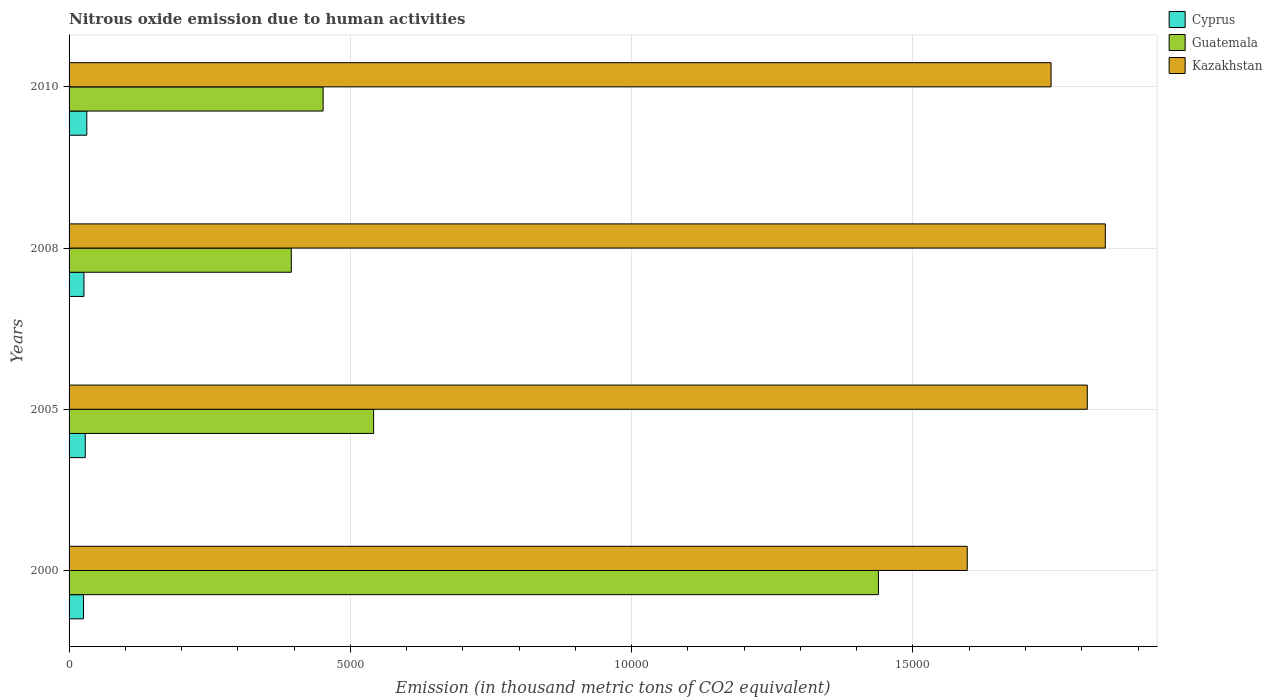How many different coloured bars are there?
Provide a succinct answer. 3. How many groups of bars are there?
Provide a succinct answer. 4. Are the number of bars on each tick of the Y-axis equal?
Offer a terse response. Yes. What is the label of the 1st group of bars from the top?
Your response must be concise. 2010. In how many cases, is the number of bars for a given year not equal to the number of legend labels?
Your answer should be very brief. 0. What is the amount of nitrous oxide emitted in Guatemala in 2005?
Your response must be concise. 5413.1. Across all years, what is the maximum amount of nitrous oxide emitted in Guatemala?
Make the answer very short. 1.44e+04. Across all years, what is the minimum amount of nitrous oxide emitted in Guatemala?
Provide a short and direct response. 3950.2. In which year was the amount of nitrous oxide emitted in Kazakhstan maximum?
Your answer should be compact. 2008. In which year was the amount of nitrous oxide emitted in Guatemala minimum?
Offer a terse response. 2008. What is the total amount of nitrous oxide emitted in Cyprus in the graph?
Offer a very short reply. 1123.4. What is the difference between the amount of nitrous oxide emitted in Kazakhstan in 2008 and that in 2010?
Keep it short and to the point. 964.4. What is the difference between the amount of nitrous oxide emitted in Cyprus in 2010 and the amount of nitrous oxide emitted in Guatemala in 2008?
Provide a succinct answer. -3635. What is the average amount of nitrous oxide emitted in Kazakhstan per year?
Give a very brief answer. 1.75e+04. In the year 2000, what is the difference between the amount of nitrous oxide emitted in Kazakhstan and amount of nitrous oxide emitted in Cyprus?
Make the answer very short. 1.57e+04. What is the ratio of the amount of nitrous oxide emitted in Cyprus in 2000 to that in 2005?
Offer a very short reply. 0.89. Is the difference between the amount of nitrous oxide emitted in Kazakhstan in 2000 and 2008 greater than the difference between the amount of nitrous oxide emitted in Cyprus in 2000 and 2008?
Provide a short and direct response. No. What is the difference between the highest and the second highest amount of nitrous oxide emitted in Guatemala?
Ensure brevity in your answer.  8972.6. What is the difference between the highest and the lowest amount of nitrous oxide emitted in Kazakhstan?
Give a very brief answer. 2454. In how many years, is the amount of nitrous oxide emitted in Kazakhstan greater than the average amount of nitrous oxide emitted in Kazakhstan taken over all years?
Your response must be concise. 2. What does the 2nd bar from the top in 2005 represents?
Your answer should be compact. Guatemala. What does the 1st bar from the bottom in 2008 represents?
Your response must be concise. Cyprus. How many bars are there?
Your answer should be very brief. 12. How many years are there in the graph?
Provide a short and direct response. 4. What is the difference between two consecutive major ticks on the X-axis?
Provide a short and direct response. 5000. Are the values on the major ticks of X-axis written in scientific E-notation?
Your answer should be very brief. No. Does the graph contain any zero values?
Give a very brief answer. No. What is the title of the graph?
Your response must be concise. Nitrous oxide emission due to human activities. What is the label or title of the X-axis?
Make the answer very short. Emission (in thousand metric tons of CO2 equivalent). What is the label or title of the Y-axis?
Offer a terse response. Years. What is the Emission (in thousand metric tons of CO2 equivalent) in Cyprus in 2000?
Offer a terse response. 255.9. What is the Emission (in thousand metric tons of CO2 equivalent) in Guatemala in 2000?
Your answer should be compact. 1.44e+04. What is the Emission (in thousand metric tons of CO2 equivalent) in Kazakhstan in 2000?
Your response must be concise. 1.60e+04. What is the Emission (in thousand metric tons of CO2 equivalent) of Cyprus in 2005?
Ensure brevity in your answer.  287.8. What is the Emission (in thousand metric tons of CO2 equivalent) in Guatemala in 2005?
Offer a very short reply. 5413.1. What is the Emission (in thousand metric tons of CO2 equivalent) of Kazakhstan in 2005?
Offer a terse response. 1.81e+04. What is the Emission (in thousand metric tons of CO2 equivalent) in Cyprus in 2008?
Your answer should be very brief. 264.5. What is the Emission (in thousand metric tons of CO2 equivalent) in Guatemala in 2008?
Provide a succinct answer. 3950.2. What is the Emission (in thousand metric tons of CO2 equivalent) of Kazakhstan in 2008?
Your answer should be compact. 1.84e+04. What is the Emission (in thousand metric tons of CO2 equivalent) of Cyprus in 2010?
Ensure brevity in your answer.  315.2. What is the Emission (in thousand metric tons of CO2 equivalent) in Guatemala in 2010?
Offer a very short reply. 4515.5. What is the Emission (in thousand metric tons of CO2 equivalent) in Kazakhstan in 2010?
Offer a very short reply. 1.75e+04. Across all years, what is the maximum Emission (in thousand metric tons of CO2 equivalent) of Cyprus?
Ensure brevity in your answer.  315.2. Across all years, what is the maximum Emission (in thousand metric tons of CO2 equivalent) in Guatemala?
Give a very brief answer. 1.44e+04. Across all years, what is the maximum Emission (in thousand metric tons of CO2 equivalent) in Kazakhstan?
Provide a succinct answer. 1.84e+04. Across all years, what is the minimum Emission (in thousand metric tons of CO2 equivalent) in Cyprus?
Your answer should be compact. 255.9. Across all years, what is the minimum Emission (in thousand metric tons of CO2 equivalent) in Guatemala?
Keep it short and to the point. 3950.2. Across all years, what is the minimum Emission (in thousand metric tons of CO2 equivalent) in Kazakhstan?
Your answer should be very brief. 1.60e+04. What is the total Emission (in thousand metric tons of CO2 equivalent) in Cyprus in the graph?
Your answer should be compact. 1123.4. What is the total Emission (in thousand metric tons of CO2 equivalent) in Guatemala in the graph?
Keep it short and to the point. 2.83e+04. What is the total Emission (in thousand metric tons of CO2 equivalent) of Kazakhstan in the graph?
Give a very brief answer. 6.99e+04. What is the difference between the Emission (in thousand metric tons of CO2 equivalent) of Cyprus in 2000 and that in 2005?
Make the answer very short. -31.9. What is the difference between the Emission (in thousand metric tons of CO2 equivalent) in Guatemala in 2000 and that in 2005?
Your response must be concise. 8972.6. What is the difference between the Emission (in thousand metric tons of CO2 equivalent) of Kazakhstan in 2000 and that in 2005?
Provide a succinct answer. -2133.3. What is the difference between the Emission (in thousand metric tons of CO2 equivalent) in Cyprus in 2000 and that in 2008?
Offer a terse response. -8.6. What is the difference between the Emission (in thousand metric tons of CO2 equivalent) in Guatemala in 2000 and that in 2008?
Keep it short and to the point. 1.04e+04. What is the difference between the Emission (in thousand metric tons of CO2 equivalent) of Kazakhstan in 2000 and that in 2008?
Your answer should be compact. -2454. What is the difference between the Emission (in thousand metric tons of CO2 equivalent) of Cyprus in 2000 and that in 2010?
Your response must be concise. -59.3. What is the difference between the Emission (in thousand metric tons of CO2 equivalent) of Guatemala in 2000 and that in 2010?
Give a very brief answer. 9870.2. What is the difference between the Emission (in thousand metric tons of CO2 equivalent) of Kazakhstan in 2000 and that in 2010?
Keep it short and to the point. -1489.6. What is the difference between the Emission (in thousand metric tons of CO2 equivalent) in Cyprus in 2005 and that in 2008?
Provide a succinct answer. 23.3. What is the difference between the Emission (in thousand metric tons of CO2 equivalent) of Guatemala in 2005 and that in 2008?
Keep it short and to the point. 1462.9. What is the difference between the Emission (in thousand metric tons of CO2 equivalent) in Kazakhstan in 2005 and that in 2008?
Provide a succinct answer. -320.7. What is the difference between the Emission (in thousand metric tons of CO2 equivalent) of Cyprus in 2005 and that in 2010?
Keep it short and to the point. -27.4. What is the difference between the Emission (in thousand metric tons of CO2 equivalent) of Guatemala in 2005 and that in 2010?
Make the answer very short. 897.6. What is the difference between the Emission (in thousand metric tons of CO2 equivalent) in Kazakhstan in 2005 and that in 2010?
Make the answer very short. 643.7. What is the difference between the Emission (in thousand metric tons of CO2 equivalent) in Cyprus in 2008 and that in 2010?
Provide a succinct answer. -50.7. What is the difference between the Emission (in thousand metric tons of CO2 equivalent) of Guatemala in 2008 and that in 2010?
Make the answer very short. -565.3. What is the difference between the Emission (in thousand metric tons of CO2 equivalent) of Kazakhstan in 2008 and that in 2010?
Offer a very short reply. 964.4. What is the difference between the Emission (in thousand metric tons of CO2 equivalent) of Cyprus in 2000 and the Emission (in thousand metric tons of CO2 equivalent) of Guatemala in 2005?
Provide a short and direct response. -5157.2. What is the difference between the Emission (in thousand metric tons of CO2 equivalent) in Cyprus in 2000 and the Emission (in thousand metric tons of CO2 equivalent) in Kazakhstan in 2005?
Provide a succinct answer. -1.78e+04. What is the difference between the Emission (in thousand metric tons of CO2 equivalent) of Guatemala in 2000 and the Emission (in thousand metric tons of CO2 equivalent) of Kazakhstan in 2005?
Ensure brevity in your answer.  -3712.1. What is the difference between the Emission (in thousand metric tons of CO2 equivalent) of Cyprus in 2000 and the Emission (in thousand metric tons of CO2 equivalent) of Guatemala in 2008?
Provide a succinct answer. -3694.3. What is the difference between the Emission (in thousand metric tons of CO2 equivalent) in Cyprus in 2000 and the Emission (in thousand metric tons of CO2 equivalent) in Kazakhstan in 2008?
Make the answer very short. -1.82e+04. What is the difference between the Emission (in thousand metric tons of CO2 equivalent) in Guatemala in 2000 and the Emission (in thousand metric tons of CO2 equivalent) in Kazakhstan in 2008?
Ensure brevity in your answer.  -4032.8. What is the difference between the Emission (in thousand metric tons of CO2 equivalent) of Cyprus in 2000 and the Emission (in thousand metric tons of CO2 equivalent) of Guatemala in 2010?
Your response must be concise. -4259.6. What is the difference between the Emission (in thousand metric tons of CO2 equivalent) in Cyprus in 2000 and the Emission (in thousand metric tons of CO2 equivalent) in Kazakhstan in 2010?
Provide a succinct answer. -1.72e+04. What is the difference between the Emission (in thousand metric tons of CO2 equivalent) of Guatemala in 2000 and the Emission (in thousand metric tons of CO2 equivalent) of Kazakhstan in 2010?
Offer a terse response. -3068.4. What is the difference between the Emission (in thousand metric tons of CO2 equivalent) of Cyprus in 2005 and the Emission (in thousand metric tons of CO2 equivalent) of Guatemala in 2008?
Offer a terse response. -3662.4. What is the difference between the Emission (in thousand metric tons of CO2 equivalent) in Cyprus in 2005 and the Emission (in thousand metric tons of CO2 equivalent) in Kazakhstan in 2008?
Give a very brief answer. -1.81e+04. What is the difference between the Emission (in thousand metric tons of CO2 equivalent) in Guatemala in 2005 and the Emission (in thousand metric tons of CO2 equivalent) in Kazakhstan in 2008?
Keep it short and to the point. -1.30e+04. What is the difference between the Emission (in thousand metric tons of CO2 equivalent) of Cyprus in 2005 and the Emission (in thousand metric tons of CO2 equivalent) of Guatemala in 2010?
Offer a very short reply. -4227.7. What is the difference between the Emission (in thousand metric tons of CO2 equivalent) of Cyprus in 2005 and the Emission (in thousand metric tons of CO2 equivalent) of Kazakhstan in 2010?
Give a very brief answer. -1.72e+04. What is the difference between the Emission (in thousand metric tons of CO2 equivalent) in Guatemala in 2005 and the Emission (in thousand metric tons of CO2 equivalent) in Kazakhstan in 2010?
Keep it short and to the point. -1.20e+04. What is the difference between the Emission (in thousand metric tons of CO2 equivalent) of Cyprus in 2008 and the Emission (in thousand metric tons of CO2 equivalent) of Guatemala in 2010?
Your response must be concise. -4251. What is the difference between the Emission (in thousand metric tons of CO2 equivalent) of Cyprus in 2008 and the Emission (in thousand metric tons of CO2 equivalent) of Kazakhstan in 2010?
Make the answer very short. -1.72e+04. What is the difference between the Emission (in thousand metric tons of CO2 equivalent) of Guatemala in 2008 and the Emission (in thousand metric tons of CO2 equivalent) of Kazakhstan in 2010?
Offer a terse response. -1.35e+04. What is the average Emission (in thousand metric tons of CO2 equivalent) in Cyprus per year?
Your response must be concise. 280.85. What is the average Emission (in thousand metric tons of CO2 equivalent) of Guatemala per year?
Offer a very short reply. 7066.12. What is the average Emission (in thousand metric tons of CO2 equivalent) in Kazakhstan per year?
Your response must be concise. 1.75e+04. In the year 2000, what is the difference between the Emission (in thousand metric tons of CO2 equivalent) in Cyprus and Emission (in thousand metric tons of CO2 equivalent) in Guatemala?
Give a very brief answer. -1.41e+04. In the year 2000, what is the difference between the Emission (in thousand metric tons of CO2 equivalent) of Cyprus and Emission (in thousand metric tons of CO2 equivalent) of Kazakhstan?
Give a very brief answer. -1.57e+04. In the year 2000, what is the difference between the Emission (in thousand metric tons of CO2 equivalent) in Guatemala and Emission (in thousand metric tons of CO2 equivalent) in Kazakhstan?
Offer a very short reply. -1578.8. In the year 2005, what is the difference between the Emission (in thousand metric tons of CO2 equivalent) of Cyprus and Emission (in thousand metric tons of CO2 equivalent) of Guatemala?
Provide a short and direct response. -5125.3. In the year 2005, what is the difference between the Emission (in thousand metric tons of CO2 equivalent) in Cyprus and Emission (in thousand metric tons of CO2 equivalent) in Kazakhstan?
Give a very brief answer. -1.78e+04. In the year 2005, what is the difference between the Emission (in thousand metric tons of CO2 equivalent) in Guatemala and Emission (in thousand metric tons of CO2 equivalent) in Kazakhstan?
Ensure brevity in your answer.  -1.27e+04. In the year 2008, what is the difference between the Emission (in thousand metric tons of CO2 equivalent) of Cyprus and Emission (in thousand metric tons of CO2 equivalent) of Guatemala?
Keep it short and to the point. -3685.7. In the year 2008, what is the difference between the Emission (in thousand metric tons of CO2 equivalent) in Cyprus and Emission (in thousand metric tons of CO2 equivalent) in Kazakhstan?
Your answer should be compact. -1.82e+04. In the year 2008, what is the difference between the Emission (in thousand metric tons of CO2 equivalent) in Guatemala and Emission (in thousand metric tons of CO2 equivalent) in Kazakhstan?
Provide a short and direct response. -1.45e+04. In the year 2010, what is the difference between the Emission (in thousand metric tons of CO2 equivalent) in Cyprus and Emission (in thousand metric tons of CO2 equivalent) in Guatemala?
Your answer should be compact. -4200.3. In the year 2010, what is the difference between the Emission (in thousand metric tons of CO2 equivalent) in Cyprus and Emission (in thousand metric tons of CO2 equivalent) in Kazakhstan?
Your answer should be very brief. -1.71e+04. In the year 2010, what is the difference between the Emission (in thousand metric tons of CO2 equivalent) in Guatemala and Emission (in thousand metric tons of CO2 equivalent) in Kazakhstan?
Offer a very short reply. -1.29e+04. What is the ratio of the Emission (in thousand metric tons of CO2 equivalent) in Cyprus in 2000 to that in 2005?
Offer a very short reply. 0.89. What is the ratio of the Emission (in thousand metric tons of CO2 equivalent) in Guatemala in 2000 to that in 2005?
Give a very brief answer. 2.66. What is the ratio of the Emission (in thousand metric tons of CO2 equivalent) in Kazakhstan in 2000 to that in 2005?
Give a very brief answer. 0.88. What is the ratio of the Emission (in thousand metric tons of CO2 equivalent) of Cyprus in 2000 to that in 2008?
Make the answer very short. 0.97. What is the ratio of the Emission (in thousand metric tons of CO2 equivalent) of Guatemala in 2000 to that in 2008?
Your answer should be very brief. 3.64. What is the ratio of the Emission (in thousand metric tons of CO2 equivalent) of Kazakhstan in 2000 to that in 2008?
Provide a short and direct response. 0.87. What is the ratio of the Emission (in thousand metric tons of CO2 equivalent) of Cyprus in 2000 to that in 2010?
Make the answer very short. 0.81. What is the ratio of the Emission (in thousand metric tons of CO2 equivalent) of Guatemala in 2000 to that in 2010?
Your response must be concise. 3.19. What is the ratio of the Emission (in thousand metric tons of CO2 equivalent) in Kazakhstan in 2000 to that in 2010?
Offer a very short reply. 0.91. What is the ratio of the Emission (in thousand metric tons of CO2 equivalent) of Cyprus in 2005 to that in 2008?
Your response must be concise. 1.09. What is the ratio of the Emission (in thousand metric tons of CO2 equivalent) in Guatemala in 2005 to that in 2008?
Provide a short and direct response. 1.37. What is the ratio of the Emission (in thousand metric tons of CO2 equivalent) of Kazakhstan in 2005 to that in 2008?
Provide a succinct answer. 0.98. What is the ratio of the Emission (in thousand metric tons of CO2 equivalent) in Cyprus in 2005 to that in 2010?
Provide a succinct answer. 0.91. What is the ratio of the Emission (in thousand metric tons of CO2 equivalent) in Guatemala in 2005 to that in 2010?
Your answer should be compact. 1.2. What is the ratio of the Emission (in thousand metric tons of CO2 equivalent) of Kazakhstan in 2005 to that in 2010?
Offer a very short reply. 1.04. What is the ratio of the Emission (in thousand metric tons of CO2 equivalent) of Cyprus in 2008 to that in 2010?
Offer a very short reply. 0.84. What is the ratio of the Emission (in thousand metric tons of CO2 equivalent) in Guatemala in 2008 to that in 2010?
Provide a short and direct response. 0.87. What is the ratio of the Emission (in thousand metric tons of CO2 equivalent) of Kazakhstan in 2008 to that in 2010?
Provide a short and direct response. 1.06. What is the difference between the highest and the second highest Emission (in thousand metric tons of CO2 equivalent) of Cyprus?
Provide a succinct answer. 27.4. What is the difference between the highest and the second highest Emission (in thousand metric tons of CO2 equivalent) of Guatemala?
Your response must be concise. 8972.6. What is the difference between the highest and the second highest Emission (in thousand metric tons of CO2 equivalent) of Kazakhstan?
Provide a succinct answer. 320.7. What is the difference between the highest and the lowest Emission (in thousand metric tons of CO2 equivalent) in Cyprus?
Your answer should be compact. 59.3. What is the difference between the highest and the lowest Emission (in thousand metric tons of CO2 equivalent) of Guatemala?
Keep it short and to the point. 1.04e+04. What is the difference between the highest and the lowest Emission (in thousand metric tons of CO2 equivalent) in Kazakhstan?
Your answer should be compact. 2454. 